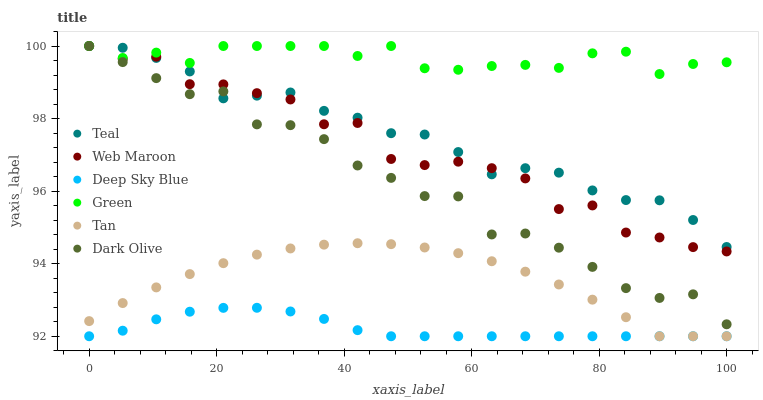Does Deep Sky Blue have the minimum area under the curve?
Answer yes or no. Yes. Does Green have the maximum area under the curve?
Answer yes or no. Yes. Does Dark Olive have the minimum area under the curve?
Answer yes or no. No. Does Dark Olive have the maximum area under the curve?
Answer yes or no. No. Is Deep Sky Blue the smoothest?
Answer yes or no. Yes. Is Web Maroon the roughest?
Answer yes or no. Yes. Is Dark Olive the smoothest?
Answer yes or no. No. Is Dark Olive the roughest?
Answer yes or no. No. Does Deep Sky Blue have the lowest value?
Answer yes or no. Yes. Does Dark Olive have the lowest value?
Answer yes or no. No. Does Green have the highest value?
Answer yes or no. Yes. Does Deep Sky Blue have the highest value?
Answer yes or no. No. Is Deep Sky Blue less than Teal?
Answer yes or no. Yes. Is Web Maroon greater than Tan?
Answer yes or no. Yes. Does Green intersect Dark Olive?
Answer yes or no. Yes. Is Green less than Dark Olive?
Answer yes or no. No. Is Green greater than Dark Olive?
Answer yes or no. No. Does Deep Sky Blue intersect Teal?
Answer yes or no. No. 